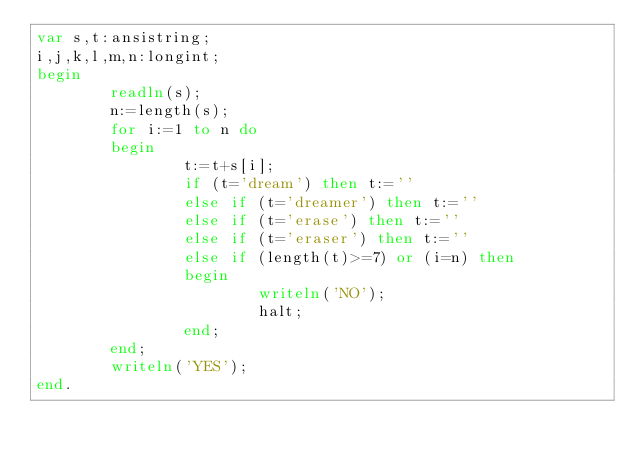Convert code to text. <code><loc_0><loc_0><loc_500><loc_500><_Pascal_>var s,t:ansistring;
i,j,k,l,m,n:longint;
begin
        readln(s);
        n:=length(s);
        for i:=1 to n do
        begin
                t:=t+s[i];
                if (t='dream') then t:=''
                else if (t='dreamer') then t:=''
                else if (t='erase') then t:=''
                else if (t='eraser') then t:=''
                else if (length(t)>=7) or (i=n) then
                begin
                        writeln('NO');
                        halt;
                end;
        end;
        writeln('YES');
end.</code> 